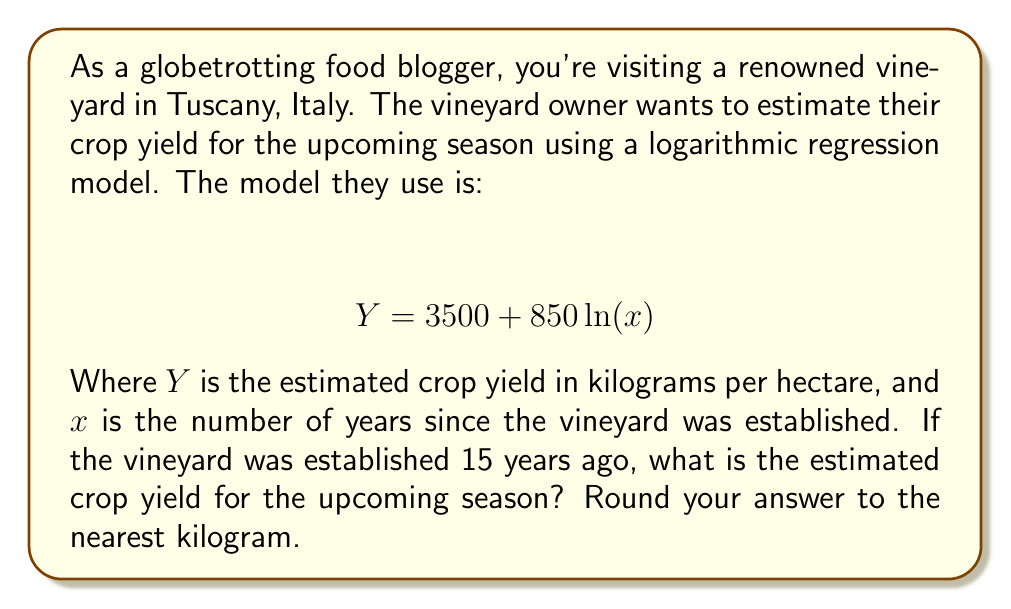Can you answer this question? To solve this problem, we need to follow these steps:

1. Identify the given information:
   - The logarithmic regression model is: $Y = 3500 + 850 \ln(x)$
   - $x$ = 15 years (time since the vineyard was established)

2. Substitute $x = 15$ into the equation:
   $$ Y = 3500 + 850 \ln(15) $$

3. Calculate $\ln(15)$ using a calculator or logarithm tables:
   $\ln(15) \approx 2.70805$

4. Substitute this value into the equation:
   $$ Y = 3500 + 850 \times 2.70805 $$

5. Multiply:
   $$ Y = 3500 + 2301.8425 $$

6. Add to get the final result:
   $$ Y = 5801.8425 $$

7. Round to the nearest kilogram:
   $$ Y \approx 5802 \text{ kg/hectare} $$

Therefore, the estimated crop yield for the upcoming season is approximately 5,802 kg per hectare.
Answer: 5,802 kg/hectare 